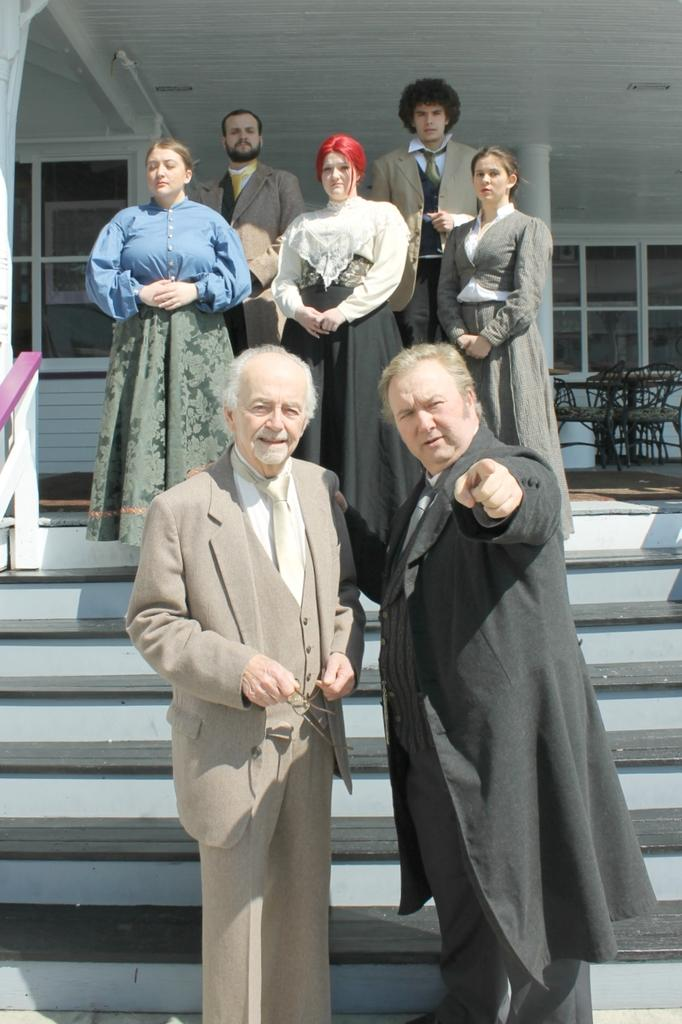How many persons can be seen in the image? There are two persons standing in the center of the image. Where are the persons standing? The persons are standing on the ground. What can be seen in the background of the image? There is a stairs, a building, windows, chairs, and other persons in the background of the image. Can you describe any architectural features in the background? Yes, there is a pillar in the background of the image. How many frogs are sitting on the chairs in the image? There are no frogs present in the image; it features two persons standing on the ground and various background elements. What type of pump is connected to the building in the image? There is no pump visible in the image; it only shows a building, stairs, windows, chairs, and other persons in the background. 